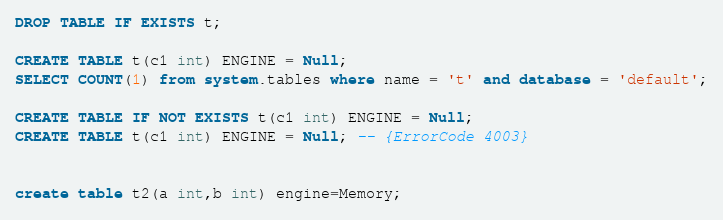<code> <loc_0><loc_0><loc_500><loc_500><_SQL_>DROP TABLE IF EXISTS t;

CREATE TABLE t(c1 int) ENGINE = Null;
SELECT COUNT(1) from system.tables where name = 't' and database = 'default';

CREATE TABLE IF NOT EXISTS t(c1 int) ENGINE = Null;
CREATE TABLE t(c1 int) ENGINE = Null; -- {ErrorCode 4003}


create table t2(a int,b int) engine=Memory;</code> 